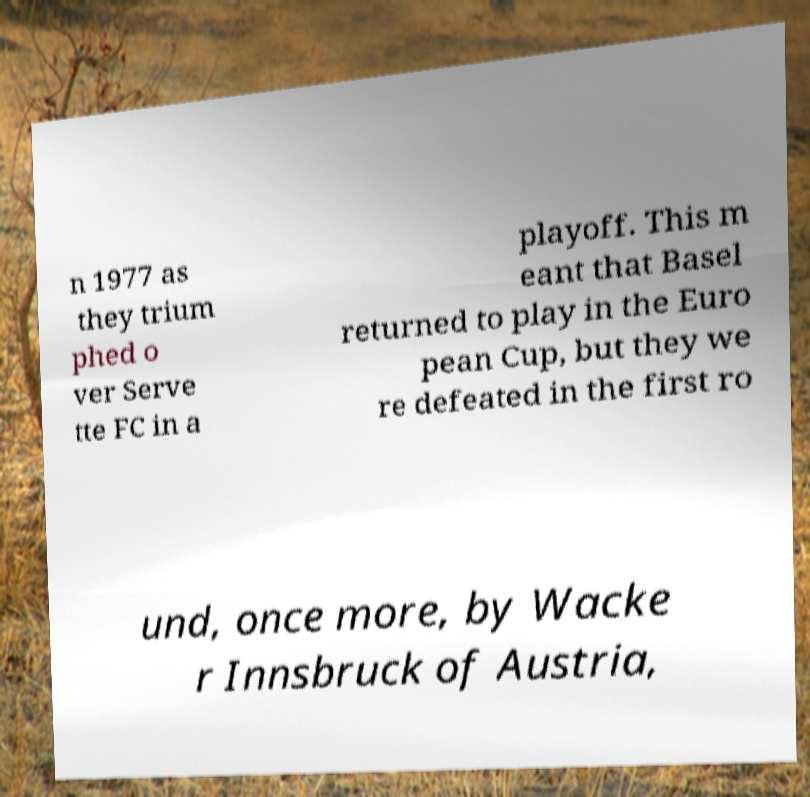Could you assist in decoding the text presented in this image and type it out clearly? n 1977 as they trium phed o ver Serve tte FC in a playoff. This m eant that Basel returned to play in the Euro pean Cup, but they we re defeated in the first ro und, once more, by Wacke r Innsbruck of Austria, 